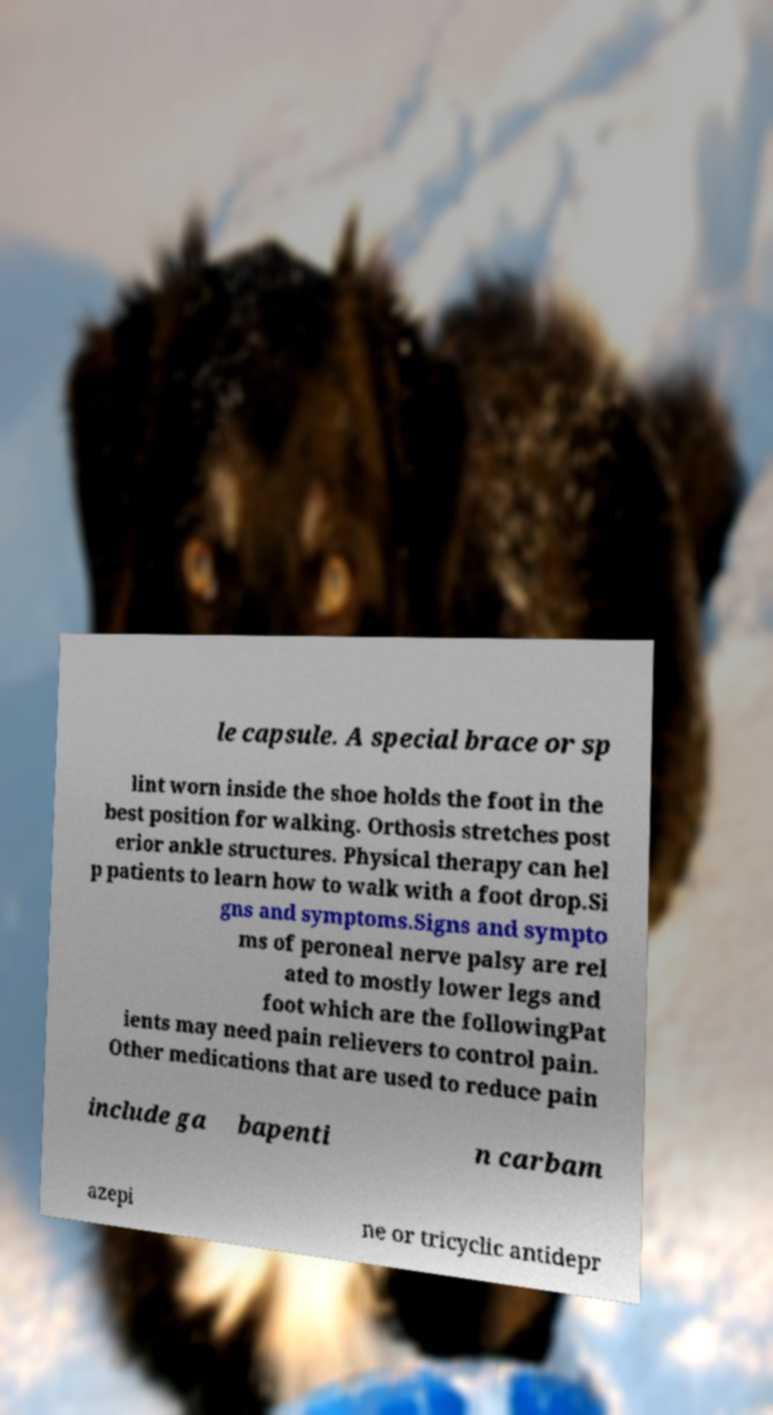For documentation purposes, I need the text within this image transcribed. Could you provide that? le capsule. A special brace or sp lint worn inside the shoe holds the foot in the best position for walking. Orthosis stretches post erior ankle structures. Physical therapy can hel p patients to learn how to walk with a foot drop.Si gns and symptoms.Signs and sympto ms of peroneal nerve palsy are rel ated to mostly lower legs and foot which are the followingPat ients may need pain relievers to control pain. Other medications that are used to reduce pain include ga bapenti n carbam azepi ne or tricyclic antidepr 